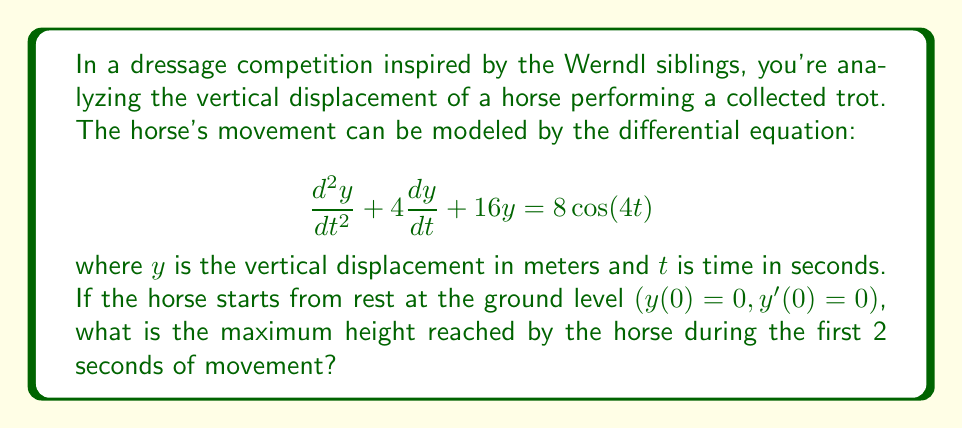Give your solution to this math problem. To solve this problem, we'll follow these steps:

1) The given differential equation is a non-homogeneous second-order linear differential equation. Its general solution will be the sum of the complementary function (solution to the homogeneous equation) and a particular integral.

2) The complementary function has the form:
   $$y_c = Ae^{-2t}\cos(2\sqrt{3}t) + Be^{-2t}\sin(2\sqrt{3}t)$$

3) A particular integral can be found using the method of undetermined coefficients:
   $$y_p = C\cos(4t) + D\sin(4t)$$

   Substituting this into the original equation gives:
   $$C = \frac{1}{2}, D = -\frac{1}{4}$$

4) The general solution is thus:
   $$y = Ae^{-2t}\cos(2\sqrt{3}t) + Be^{-2t}\sin(2\sqrt{3}t) + \frac{1}{2}\cos(4t) - \frac{1}{4}\sin(4t)$$

5) Using the initial conditions:
   $y(0) = 0$ gives $A + \frac{1}{2} = 0$, so $A = -\frac{1}{2}$
   $y'(0) = 0$ gives $-2A + 2\sqrt{3}B - 1 = 0$, so $B = \frac{1}{2\sqrt{3}}$

6) The final solution is:
   $$y = -\frac{1}{2}e^{-2t}\cos(2\sqrt{3}t) + \frac{1}{2\sqrt{3}}e^{-2t}\sin(2\sqrt{3}t) + \frac{1}{2}\cos(4t) - \frac{1}{4}\sin(4t)$$

7) To find the maximum height in the first 2 seconds, we need to find the maximum value of this function in the interval $[0,2]$. This can be done numerically using a computer algebra system or graphing calculator.

8) Using such a tool, we find that the maximum occurs at approximately $t = 0.785$ seconds and the maximum height is approximately 0.6213 meters.
Answer: 0.6213 meters 